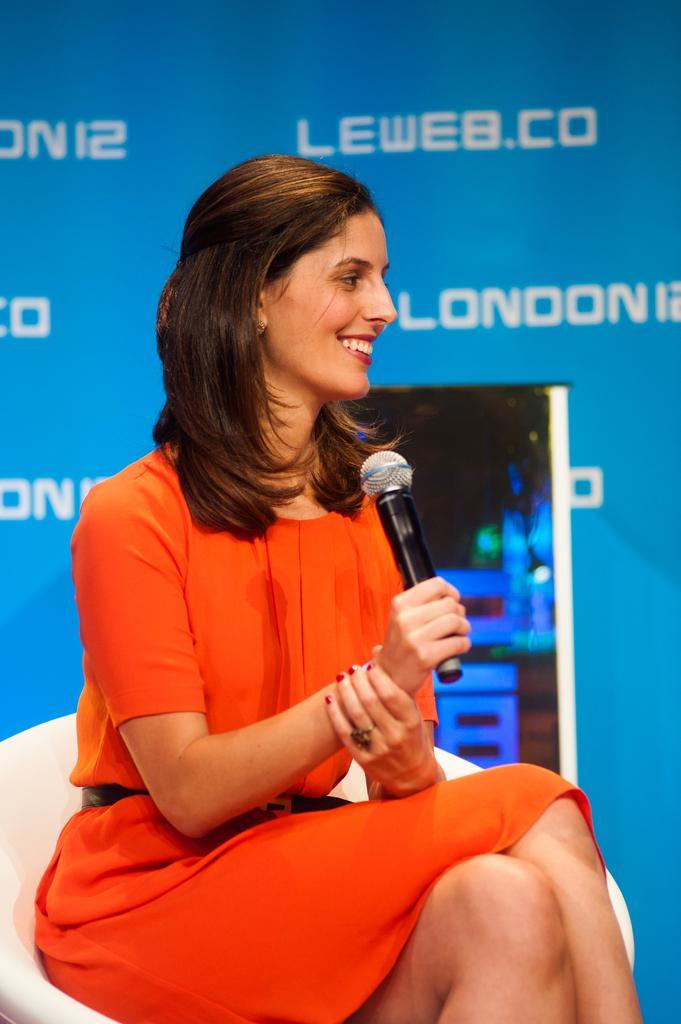Please provide a concise description of this image. In the image a woman wearing orange dress is sitting on a chair and speaking she is laughing, in the background there is a blue color logo. 